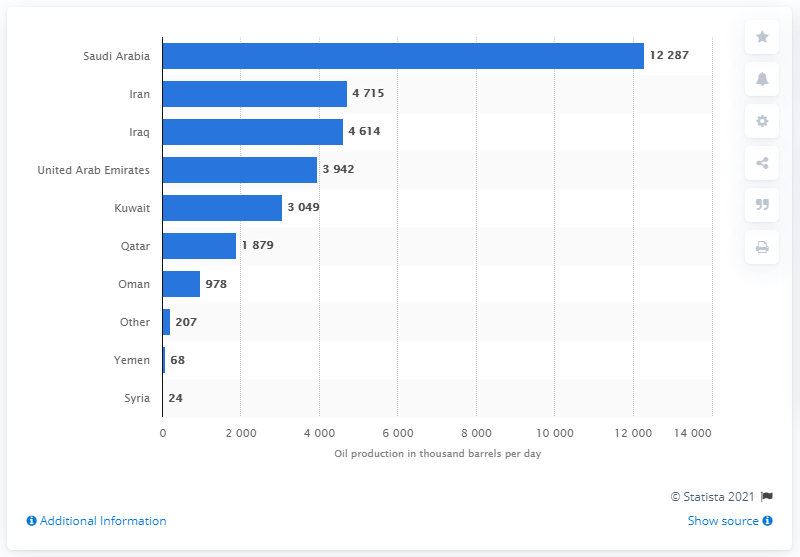Identify some key points in this picture. Saudi Arabia is the leading producer of oil in the Middle East. 